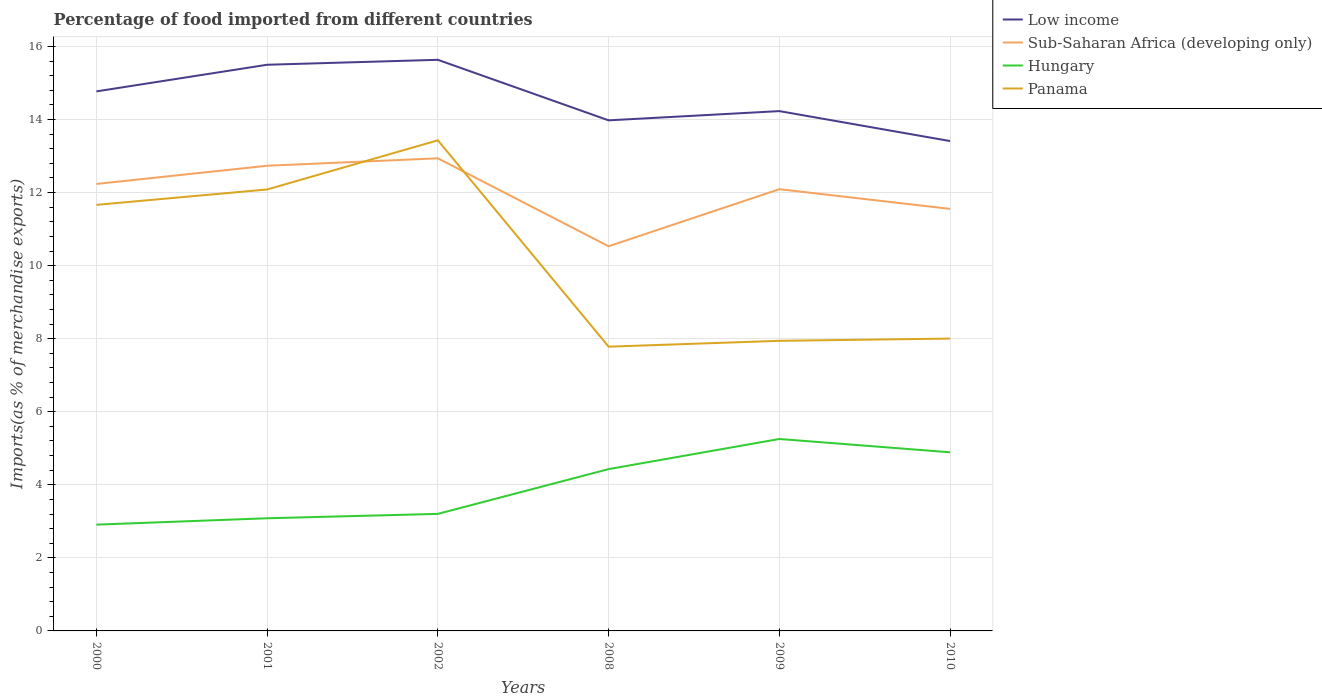How many different coloured lines are there?
Keep it short and to the point. 4. Is the number of lines equal to the number of legend labels?
Offer a terse response. Yes. Across all years, what is the maximum percentage of imports to different countries in Low income?
Provide a short and direct response. 13.41. In which year was the percentage of imports to different countries in Hungary maximum?
Offer a terse response. 2000. What is the total percentage of imports to different countries in Low income in the graph?
Your answer should be very brief. -0.14. What is the difference between the highest and the second highest percentage of imports to different countries in Low income?
Make the answer very short. 2.22. What is the difference between the highest and the lowest percentage of imports to different countries in Low income?
Your answer should be very brief. 3. How many lines are there?
Offer a very short reply. 4. What is the difference between two consecutive major ticks on the Y-axis?
Ensure brevity in your answer.  2. Are the values on the major ticks of Y-axis written in scientific E-notation?
Your answer should be compact. No. Does the graph contain any zero values?
Ensure brevity in your answer.  No. Does the graph contain grids?
Provide a short and direct response. Yes. How are the legend labels stacked?
Your answer should be very brief. Vertical. What is the title of the graph?
Offer a terse response. Percentage of food imported from different countries. What is the label or title of the X-axis?
Provide a short and direct response. Years. What is the label or title of the Y-axis?
Offer a very short reply. Imports(as % of merchandise exports). What is the Imports(as % of merchandise exports) of Low income in 2000?
Your answer should be compact. 14.77. What is the Imports(as % of merchandise exports) in Sub-Saharan Africa (developing only) in 2000?
Provide a short and direct response. 12.24. What is the Imports(as % of merchandise exports) of Hungary in 2000?
Provide a succinct answer. 2.91. What is the Imports(as % of merchandise exports) of Panama in 2000?
Make the answer very short. 11.66. What is the Imports(as % of merchandise exports) of Low income in 2001?
Make the answer very short. 15.5. What is the Imports(as % of merchandise exports) in Sub-Saharan Africa (developing only) in 2001?
Your response must be concise. 12.74. What is the Imports(as % of merchandise exports) of Hungary in 2001?
Make the answer very short. 3.08. What is the Imports(as % of merchandise exports) of Panama in 2001?
Provide a succinct answer. 12.09. What is the Imports(as % of merchandise exports) of Low income in 2002?
Provide a succinct answer. 15.64. What is the Imports(as % of merchandise exports) of Sub-Saharan Africa (developing only) in 2002?
Offer a terse response. 12.94. What is the Imports(as % of merchandise exports) in Hungary in 2002?
Offer a terse response. 3.2. What is the Imports(as % of merchandise exports) in Panama in 2002?
Your answer should be compact. 13.43. What is the Imports(as % of merchandise exports) in Low income in 2008?
Keep it short and to the point. 13.98. What is the Imports(as % of merchandise exports) in Sub-Saharan Africa (developing only) in 2008?
Offer a very short reply. 10.53. What is the Imports(as % of merchandise exports) in Hungary in 2008?
Provide a succinct answer. 4.43. What is the Imports(as % of merchandise exports) in Panama in 2008?
Give a very brief answer. 7.78. What is the Imports(as % of merchandise exports) in Low income in 2009?
Your answer should be very brief. 14.23. What is the Imports(as % of merchandise exports) in Sub-Saharan Africa (developing only) in 2009?
Offer a terse response. 12.09. What is the Imports(as % of merchandise exports) in Hungary in 2009?
Ensure brevity in your answer.  5.25. What is the Imports(as % of merchandise exports) in Panama in 2009?
Your response must be concise. 7.94. What is the Imports(as % of merchandise exports) in Low income in 2010?
Offer a very short reply. 13.41. What is the Imports(as % of merchandise exports) of Sub-Saharan Africa (developing only) in 2010?
Provide a short and direct response. 11.55. What is the Imports(as % of merchandise exports) of Hungary in 2010?
Offer a terse response. 4.89. What is the Imports(as % of merchandise exports) in Panama in 2010?
Offer a terse response. 8. Across all years, what is the maximum Imports(as % of merchandise exports) of Low income?
Your response must be concise. 15.64. Across all years, what is the maximum Imports(as % of merchandise exports) in Sub-Saharan Africa (developing only)?
Provide a succinct answer. 12.94. Across all years, what is the maximum Imports(as % of merchandise exports) of Hungary?
Your response must be concise. 5.25. Across all years, what is the maximum Imports(as % of merchandise exports) of Panama?
Offer a terse response. 13.43. Across all years, what is the minimum Imports(as % of merchandise exports) of Low income?
Your answer should be compact. 13.41. Across all years, what is the minimum Imports(as % of merchandise exports) in Sub-Saharan Africa (developing only)?
Provide a succinct answer. 10.53. Across all years, what is the minimum Imports(as % of merchandise exports) of Hungary?
Keep it short and to the point. 2.91. Across all years, what is the minimum Imports(as % of merchandise exports) of Panama?
Offer a very short reply. 7.78. What is the total Imports(as % of merchandise exports) in Low income in the graph?
Your answer should be very brief. 87.53. What is the total Imports(as % of merchandise exports) of Sub-Saharan Africa (developing only) in the graph?
Provide a succinct answer. 72.09. What is the total Imports(as % of merchandise exports) in Hungary in the graph?
Offer a very short reply. 23.77. What is the total Imports(as % of merchandise exports) of Panama in the graph?
Give a very brief answer. 60.91. What is the difference between the Imports(as % of merchandise exports) in Low income in 2000 and that in 2001?
Make the answer very short. -0.73. What is the difference between the Imports(as % of merchandise exports) in Sub-Saharan Africa (developing only) in 2000 and that in 2001?
Give a very brief answer. -0.5. What is the difference between the Imports(as % of merchandise exports) of Hungary in 2000 and that in 2001?
Offer a very short reply. -0.17. What is the difference between the Imports(as % of merchandise exports) of Panama in 2000 and that in 2001?
Make the answer very short. -0.42. What is the difference between the Imports(as % of merchandise exports) in Low income in 2000 and that in 2002?
Give a very brief answer. -0.86. What is the difference between the Imports(as % of merchandise exports) in Sub-Saharan Africa (developing only) in 2000 and that in 2002?
Offer a very short reply. -0.7. What is the difference between the Imports(as % of merchandise exports) of Hungary in 2000 and that in 2002?
Provide a short and direct response. -0.29. What is the difference between the Imports(as % of merchandise exports) of Panama in 2000 and that in 2002?
Your response must be concise. -1.77. What is the difference between the Imports(as % of merchandise exports) of Low income in 2000 and that in 2008?
Provide a short and direct response. 0.79. What is the difference between the Imports(as % of merchandise exports) of Sub-Saharan Africa (developing only) in 2000 and that in 2008?
Ensure brevity in your answer.  1.71. What is the difference between the Imports(as % of merchandise exports) in Hungary in 2000 and that in 2008?
Your answer should be compact. -1.52. What is the difference between the Imports(as % of merchandise exports) of Panama in 2000 and that in 2008?
Provide a succinct answer. 3.88. What is the difference between the Imports(as % of merchandise exports) in Low income in 2000 and that in 2009?
Make the answer very short. 0.54. What is the difference between the Imports(as % of merchandise exports) in Sub-Saharan Africa (developing only) in 2000 and that in 2009?
Provide a succinct answer. 0.14. What is the difference between the Imports(as % of merchandise exports) of Hungary in 2000 and that in 2009?
Provide a short and direct response. -2.35. What is the difference between the Imports(as % of merchandise exports) in Panama in 2000 and that in 2009?
Make the answer very short. 3.72. What is the difference between the Imports(as % of merchandise exports) in Low income in 2000 and that in 2010?
Offer a terse response. 1.36. What is the difference between the Imports(as % of merchandise exports) in Sub-Saharan Africa (developing only) in 2000 and that in 2010?
Your answer should be very brief. 0.68. What is the difference between the Imports(as % of merchandise exports) of Hungary in 2000 and that in 2010?
Provide a short and direct response. -1.98. What is the difference between the Imports(as % of merchandise exports) of Panama in 2000 and that in 2010?
Provide a short and direct response. 3.66. What is the difference between the Imports(as % of merchandise exports) of Low income in 2001 and that in 2002?
Ensure brevity in your answer.  -0.14. What is the difference between the Imports(as % of merchandise exports) of Sub-Saharan Africa (developing only) in 2001 and that in 2002?
Keep it short and to the point. -0.2. What is the difference between the Imports(as % of merchandise exports) of Hungary in 2001 and that in 2002?
Offer a very short reply. -0.12. What is the difference between the Imports(as % of merchandise exports) of Panama in 2001 and that in 2002?
Your answer should be very brief. -1.35. What is the difference between the Imports(as % of merchandise exports) in Low income in 2001 and that in 2008?
Ensure brevity in your answer.  1.52. What is the difference between the Imports(as % of merchandise exports) in Sub-Saharan Africa (developing only) in 2001 and that in 2008?
Your answer should be compact. 2.2. What is the difference between the Imports(as % of merchandise exports) in Hungary in 2001 and that in 2008?
Offer a terse response. -1.35. What is the difference between the Imports(as % of merchandise exports) of Panama in 2001 and that in 2008?
Make the answer very short. 4.3. What is the difference between the Imports(as % of merchandise exports) of Low income in 2001 and that in 2009?
Provide a short and direct response. 1.27. What is the difference between the Imports(as % of merchandise exports) of Sub-Saharan Africa (developing only) in 2001 and that in 2009?
Make the answer very short. 0.64. What is the difference between the Imports(as % of merchandise exports) of Hungary in 2001 and that in 2009?
Provide a succinct answer. -2.17. What is the difference between the Imports(as % of merchandise exports) in Panama in 2001 and that in 2009?
Ensure brevity in your answer.  4.14. What is the difference between the Imports(as % of merchandise exports) of Low income in 2001 and that in 2010?
Ensure brevity in your answer.  2.09. What is the difference between the Imports(as % of merchandise exports) in Sub-Saharan Africa (developing only) in 2001 and that in 2010?
Give a very brief answer. 1.18. What is the difference between the Imports(as % of merchandise exports) in Hungary in 2001 and that in 2010?
Your answer should be compact. -1.81. What is the difference between the Imports(as % of merchandise exports) of Panama in 2001 and that in 2010?
Ensure brevity in your answer.  4.08. What is the difference between the Imports(as % of merchandise exports) of Low income in 2002 and that in 2008?
Your response must be concise. 1.66. What is the difference between the Imports(as % of merchandise exports) in Sub-Saharan Africa (developing only) in 2002 and that in 2008?
Your answer should be compact. 2.41. What is the difference between the Imports(as % of merchandise exports) of Hungary in 2002 and that in 2008?
Offer a terse response. -1.23. What is the difference between the Imports(as % of merchandise exports) in Panama in 2002 and that in 2008?
Your response must be concise. 5.65. What is the difference between the Imports(as % of merchandise exports) of Low income in 2002 and that in 2009?
Provide a short and direct response. 1.4. What is the difference between the Imports(as % of merchandise exports) in Sub-Saharan Africa (developing only) in 2002 and that in 2009?
Your answer should be very brief. 0.85. What is the difference between the Imports(as % of merchandise exports) in Hungary in 2002 and that in 2009?
Provide a short and direct response. -2.05. What is the difference between the Imports(as % of merchandise exports) in Panama in 2002 and that in 2009?
Offer a very short reply. 5.49. What is the difference between the Imports(as % of merchandise exports) of Low income in 2002 and that in 2010?
Provide a short and direct response. 2.22. What is the difference between the Imports(as % of merchandise exports) of Sub-Saharan Africa (developing only) in 2002 and that in 2010?
Give a very brief answer. 1.38. What is the difference between the Imports(as % of merchandise exports) of Hungary in 2002 and that in 2010?
Your answer should be compact. -1.69. What is the difference between the Imports(as % of merchandise exports) of Panama in 2002 and that in 2010?
Give a very brief answer. 5.43. What is the difference between the Imports(as % of merchandise exports) of Low income in 2008 and that in 2009?
Make the answer very short. -0.25. What is the difference between the Imports(as % of merchandise exports) of Sub-Saharan Africa (developing only) in 2008 and that in 2009?
Provide a short and direct response. -1.56. What is the difference between the Imports(as % of merchandise exports) in Hungary in 2008 and that in 2009?
Keep it short and to the point. -0.82. What is the difference between the Imports(as % of merchandise exports) in Panama in 2008 and that in 2009?
Provide a succinct answer. -0.16. What is the difference between the Imports(as % of merchandise exports) in Low income in 2008 and that in 2010?
Give a very brief answer. 0.57. What is the difference between the Imports(as % of merchandise exports) in Sub-Saharan Africa (developing only) in 2008 and that in 2010?
Give a very brief answer. -1.02. What is the difference between the Imports(as % of merchandise exports) in Hungary in 2008 and that in 2010?
Your response must be concise. -0.46. What is the difference between the Imports(as % of merchandise exports) of Panama in 2008 and that in 2010?
Your response must be concise. -0.22. What is the difference between the Imports(as % of merchandise exports) of Low income in 2009 and that in 2010?
Ensure brevity in your answer.  0.82. What is the difference between the Imports(as % of merchandise exports) of Sub-Saharan Africa (developing only) in 2009 and that in 2010?
Give a very brief answer. 0.54. What is the difference between the Imports(as % of merchandise exports) in Hungary in 2009 and that in 2010?
Your response must be concise. 0.36. What is the difference between the Imports(as % of merchandise exports) of Panama in 2009 and that in 2010?
Make the answer very short. -0.06. What is the difference between the Imports(as % of merchandise exports) in Low income in 2000 and the Imports(as % of merchandise exports) in Sub-Saharan Africa (developing only) in 2001?
Provide a short and direct response. 2.04. What is the difference between the Imports(as % of merchandise exports) of Low income in 2000 and the Imports(as % of merchandise exports) of Hungary in 2001?
Your response must be concise. 11.69. What is the difference between the Imports(as % of merchandise exports) of Low income in 2000 and the Imports(as % of merchandise exports) of Panama in 2001?
Keep it short and to the point. 2.69. What is the difference between the Imports(as % of merchandise exports) of Sub-Saharan Africa (developing only) in 2000 and the Imports(as % of merchandise exports) of Hungary in 2001?
Your answer should be very brief. 9.15. What is the difference between the Imports(as % of merchandise exports) in Sub-Saharan Africa (developing only) in 2000 and the Imports(as % of merchandise exports) in Panama in 2001?
Your answer should be compact. 0.15. What is the difference between the Imports(as % of merchandise exports) in Hungary in 2000 and the Imports(as % of merchandise exports) in Panama in 2001?
Ensure brevity in your answer.  -9.18. What is the difference between the Imports(as % of merchandise exports) of Low income in 2000 and the Imports(as % of merchandise exports) of Sub-Saharan Africa (developing only) in 2002?
Provide a succinct answer. 1.83. What is the difference between the Imports(as % of merchandise exports) of Low income in 2000 and the Imports(as % of merchandise exports) of Hungary in 2002?
Make the answer very short. 11.57. What is the difference between the Imports(as % of merchandise exports) in Low income in 2000 and the Imports(as % of merchandise exports) in Panama in 2002?
Your answer should be compact. 1.34. What is the difference between the Imports(as % of merchandise exports) of Sub-Saharan Africa (developing only) in 2000 and the Imports(as % of merchandise exports) of Hungary in 2002?
Provide a short and direct response. 9.03. What is the difference between the Imports(as % of merchandise exports) in Sub-Saharan Africa (developing only) in 2000 and the Imports(as % of merchandise exports) in Panama in 2002?
Make the answer very short. -1.19. What is the difference between the Imports(as % of merchandise exports) of Hungary in 2000 and the Imports(as % of merchandise exports) of Panama in 2002?
Ensure brevity in your answer.  -10.52. What is the difference between the Imports(as % of merchandise exports) in Low income in 2000 and the Imports(as % of merchandise exports) in Sub-Saharan Africa (developing only) in 2008?
Give a very brief answer. 4.24. What is the difference between the Imports(as % of merchandise exports) in Low income in 2000 and the Imports(as % of merchandise exports) in Hungary in 2008?
Your answer should be very brief. 10.34. What is the difference between the Imports(as % of merchandise exports) in Low income in 2000 and the Imports(as % of merchandise exports) in Panama in 2008?
Your answer should be compact. 6.99. What is the difference between the Imports(as % of merchandise exports) in Sub-Saharan Africa (developing only) in 2000 and the Imports(as % of merchandise exports) in Hungary in 2008?
Provide a succinct answer. 7.81. What is the difference between the Imports(as % of merchandise exports) in Sub-Saharan Africa (developing only) in 2000 and the Imports(as % of merchandise exports) in Panama in 2008?
Your answer should be very brief. 4.46. What is the difference between the Imports(as % of merchandise exports) in Hungary in 2000 and the Imports(as % of merchandise exports) in Panama in 2008?
Ensure brevity in your answer.  -4.87. What is the difference between the Imports(as % of merchandise exports) of Low income in 2000 and the Imports(as % of merchandise exports) of Sub-Saharan Africa (developing only) in 2009?
Your answer should be very brief. 2.68. What is the difference between the Imports(as % of merchandise exports) of Low income in 2000 and the Imports(as % of merchandise exports) of Hungary in 2009?
Provide a short and direct response. 9.52. What is the difference between the Imports(as % of merchandise exports) of Low income in 2000 and the Imports(as % of merchandise exports) of Panama in 2009?
Ensure brevity in your answer.  6.83. What is the difference between the Imports(as % of merchandise exports) in Sub-Saharan Africa (developing only) in 2000 and the Imports(as % of merchandise exports) in Hungary in 2009?
Your answer should be compact. 6.98. What is the difference between the Imports(as % of merchandise exports) in Sub-Saharan Africa (developing only) in 2000 and the Imports(as % of merchandise exports) in Panama in 2009?
Your response must be concise. 4.29. What is the difference between the Imports(as % of merchandise exports) in Hungary in 2000 and the Imports(as % of merchandise exports) in Panama in 2009?
Make the answer very short. -5.03. What is the difference between the Imports(as % of merchandise exports) in Low income in 2000 and the Imports(as % of merchandise exports) in Sub-Saharan Africa (developing only) in 2010?
Offer a very short reply. 3.22. What is the difference between the Imports(as % of merchandise exports) in Low income in 2000 and the Imports(as % of merchandise exports) in Hungary in 2010?
Keep it short and to the point. 9.88. What is the difference between the Imports(as % of merchandise exports) of Low income in 2000 and the Imports(as % of merchandise exports) of Panama in 2010?
Make the answer very short. 6.77. What is the difference between the Imports(as % of merchandise exports) in Sub-Saharan Africa (developing only) in 2000 and the Imports(as % of merchandise exports) in Hungary in 2010?
Your answer should be very brief. 7.35. What is the difference between the Imports(as % of merchandise exports) in Sub-Saharan Africa (developing only) in 2000 and the Imports(as % of merchandise exports) in Panama in 2010?
Ensure brevity in your answer.  4.23. What is the difference between the Imports(as % of merchandise exports) in Hungary in 2000 and the Imports(as % of merchandise exports) in Panama in 2010?
Offer a very short reply. -5.09. What is the difference between the Imports(as % of merchandise exports) in Low income in 2001 and the Imports(as % of merchandise exports) in Sub-Saharan Africa (developing only) in 2002?
Your answer should be very brief. 2.56. What is the difference between the Imports(as % of merchandise exports) in Low income in 2001 and the Imports(as % of merchandise exports) in Hungary in 2002?
Ensure brevity in your answer.  12.3. What is the difference between the Imports(as % of merchandise exports) of Low income in 2001 and the Imports(as % of merchandise exports) of Panama in 2002?
Provide a short and direct response. 2.07. What is the difference between the Imports(as % of merchandise exports) of Sub-Saharan Africa (developing only) in 2001 and the Imports(as % of merchandise exports) of Hungary in 2002?
Give a very brief answer. 9.53. What is the difference between the Imports(as % of merchandise exports) in Sub-Saharan Africa (developing only) in 2001 and the Imports(as % of merchandise exports) in Panama in 2002?
Make the answer very short. -0.7. What is the difference between the Imports(as % of merchandise exports) in Hungary in 2001 and the Imports(as % of merchandise exports) in Panama in 2002?
Keep it short and to the point. -10.35. What is the difference between the Imports(as % of merchandise exports) in Low income in 2001 and the Imports(as % of merchandise exports) in Sub-Saharan Africa (developing only) in 2008?
Your answer should be very brief. 4.97. What is the difference between the Imports(as % of merchandise exports) in Low income in 2001 and the Imports(as % of merchandise exports) in Hungary in 2008?
Provide a short and direct response. 11.07. What is the difference between the Imports(as % of merchandise exports) of Low income in 2001 and the Imports(as % of merchandise exports) of Panama in 2008?
Your response must be concise. 7.72. What is the difference between the Imports(as % of merchandise exports) in Sub-Saharan Africa (developing only) in 2001 and the Imports(as % of merchandise exports) in Hungary in 2008?
Your response must be concise. 8.31. What is the difference between the Imports(as % of merchandise exports) in Sub-Saharan Africa (developing only) in 2001 and the Imports(as % of merchandise exports) in Panama in 2008?
Your answer should be compact. 4.95. What is the difference between the Imports(as % of merchandise exports) of Hungary in 2001 and the Imports(as % of merchandise exports) of Panama in 2008?
Provide a succinct answer. -4.7. What is the difference between the Imports(as % of merchandise exports) of Low income in 2001 and the Imports(as % of merchandise exports) of Sub-Saharan Africa (developing only) in 2009?
Provide a succinct answer. 3.41. What is the difference between the Imports(as % of merchandise exports) of Low income in 2001 and the Imports(as % of merchandise exports) of Hungary in 2009?
Your answer should be very brief. 10.25. What is the difference between the Imports(as % of merchandise exports) of Low income in 2001 and the Imports(as % of merchandise exports) of Panama in 2009?
Your response must be concise. 7.56. What is the difference between the Imports(as % of merchandise exports) of Sub-Saharan Africa (developing only) in 2001 and the Imports(as % of merchandise exports) of Hungary in 2009?
Offer a terse response. 7.48. What is the difference between the Imports(as % of merchandise exports) in Sub-Saharan Africa (developing only) in 2001 and the Imports(as % of merchandise exports) in Panama in 2009?
Your answer should be very brief. 4.79. What is the difference between the Imports(as % of merchandise exports) of Hungary in 2001 and the Imports(as % of merchandise exports) of Panama in 2009?
Give a very brief answer. -4.86. What is the difference between the Imports(as % of merchandise exports) of Low income in 2001 and the Imports(as % of merchandise exports) of Sub-Saharan Africa (developing only) in 2010?
Your answer should be very brief. 3.95. What is the difference between the Imports(as % of merchandise exports) of Low income in 2001 and the Imports(as % of merchandise exports) of Hungary in 2010?
Offer a very short reply. 10.61. What is the difference between the Imports(as % of merchandise exports) of Low income in 2001 and the Imports(as % of merchandise exports) of Panama in 2010?
Your answer should be compact. 7.5. What is the difference between the Imports(as % of merchandise exports) in Sub-Saharan Africa (developing only) in 2001 and the Imports(as % of merchandise exports) in Hungary in 2010?
Your answer should be compact. 7.84. What is the difference between the Imports(as % of merchandise exports) of Sub-Saharan Africa (developing only) in 2001 and the Imports(as % of merchandise exports) of Panama in 2010?
Offer a very short reply. 4.73. What is the difference between the Imports(as % of merchandise exports) of Hungary in 2001 and the Imports(as % of merchandise exports) of Panama in 2010?
Offer a very short reply. -4.92. What is the difference between the Imports(as % of merchandise exports) in Low income in 2002 and the Imports(as % of merchandise exports) in Sub-Saharan Africa (developing only) in 2008?
Keep it short and to the point. 5.1. What is the difference between the Imports(as % of merchandise exports) of Low income in 2002 and the Imports(as % of merchandise exports) of Hungary in 2008?
Your response must be concise. 11.21. What is the difference between the Imports(as % of merchandise exports) in Low income in 2002 and the Imports(as % of merchandise exports) in Panama in 2008?
Provide a short and direct response. 7.85. What is the difference between the Imports(as % of merchandise exports) of Sub-Saharan Africa (developing only) in 2002 and the Imports(as % of merchandise exports) of Hungary in 2008?
Provide a succinct answer. 8.51. What is the difference between the Imports(as % of merchandise exports) of Sub-Saharan Africa (developing only) in 2002 and the Imports(as % of merchandise exports) of Panama in 2008?
Provide a succinct answer. 5.16. What is the difference between the Imports(as % of merchandise exports) of Hungary in 2002 and the Imports(as % of merchandise exports) of Panama in 2008?
Give a very brief answer. -4.58. What is the difference between the Imports(as % of merchandise exports) of Low income in 2002 and the Imports(as % of merchandise exports) of Sub-Saharan Africa (developing only) in 2009?
Your answer should be compact. 3.54. What is the difference between the Imports(as % of merchandise exports) in Low income in 2002 and the Imports(as % of merchandise exports) in Hungary in 2009?
Give a very brief answer. 10.38. What is the difference between the Imports(as % of merchandise exports) of Low income in 2002 and the Imports(as % of merchandise exports) of Panama in 2009?
Provide a succinct answer. 7.69. What is the difference between the Imports(as % of merchandise exports) of Sub-Saharan Africa (developing only) in 2002 and the Imports(as % of merchandise exports) of Hungary in 2009?
Give a very brief answer. 7.68. What is the difference between the Imports(as % of merchandise exports) in Sub-Saharan Africa (developing only) in 2002 and the Imports(as % of merchandise exports) in Panama in 2009?
Provide a succinct answer. 5. What is the difference between the Imports(as % of merchandise exports) in Hungary in 2002 and the Imports(as % of merchandise exports) in Panama in 2009?
Give a very brief answer. -4.74. What is the difference between the Imports(as % of merchandise exports) in Low income in 2002 and the Imports(as % of merchandise exports) in Sub-Saharan Africa (developing only) in 2010?
Ensure brevity in your answer.  4.08. What is the difference between the Imports(as % of merchandise exports) of Low income in 2002 and the Imports(as % of merchandise exports) of Hungary in 2010?
Keep it short and to the point. 10.74. What is the difference between the Imports(as % of merchandise exports) of Low income in 2002 and the Imports(as % of merchandise exports) of Panama in 2010?
Give a very brief answer. 7.63. What is the difference between the Imports(as % of merchandise exports) of Sub-Saharan Africa (developing only) in 2002 and the Imports(as % of merchandise exports) of Hungary in 2010?
Provide a short and direct response. 8.05. What is the difference between the Imports(as % of merchandise exports) of Sub-Saharan Africa (developing only) in 2002 and the Imports(as % of merchandise exports) of Panama in 2010?
Give a very brief answer. 4.94. What is the difference between the Imports(as % of merchandise exports) of Hungary in 2002 and the Imports(as % of merchandise exports) of Panama in 2010?
Your answer should be very brief. -4.8. What is the difference between the Imports(as % of merchandise exports) in Low income in 2008 and the Imports(as % of merchandise exports) in Sub-Saharan Africa (developing only) in 2009?
Your answer should be compact. 1.89. What is the difference between the Imports(as % of merchandise exports) of Low income in 2008 and the Imports(as % of merchandise exports) of Hungary in 2009?
Keep it short and to the point. 8.72. What is the difference between the Imports(as % of merchandise exports) in Low income in 2008 and the Imports(as % of merchandise exports) in Panama in 2009?
Make the answer very short. 6.04. What is the difference between the Imports(as % of merchandise exports) in Sub-Saharan Africa (developing only) in 2008 and the Imports(as % of merchandise exports) in Hungary in 2009?
Your answer should be very brief. 5.28. What is the difference between the Imports(as % of merchandise exports) in Sub-Saharan Africa (developing only) in 2008 and the Imports(as % of merchandise exports) in Panama in 2009?
Provide a succinct answer. 2.59. What is the difference between the Imports(as % of merchandise exports) of Hungary in 2008 and the Imports(as % of merchandise exports) of Panama in 2009?
Provide a succinct answer. -3.51. What is the difference between the Imports(as % of merchandise exports) in Low income in 2008 and the Imports(as % of merchandise exports) in Sub-Saharan Africa (developing only) in 2010?
Make the answer very short. 2.42. What is the difference between the Imports(as % of merchandise exports) in Low income in 2008 and the Imports(as % of merchandise exports) in Hungary in 2010?
Your answer should be very brief. 9.09. What is the difference between the Imports(as % of merchandise exports) of Low income in 2008 and the Imports(as % of merchandise exports) of Panama in 2010?
Offer a very short reply. 5.97. What is the difference between the Imports(as % of merchandise exports) of Sub-Saharan Africa (developing only) in 2008 and the Imports(as % of merchandise exports) of Hungary in 2010?
Keep it short and to the point. 5.64. What is the difference between the Imports(as % of merchandise exports) in Sub-Saharan Africa (developing only) in 2008 and the Imports(as % of merchandise exports) in Panama in 2010?
Your response must be concise. 2.53. What is the difference between the Imports(as % of merchandise exports) in Hungary in 2008 and the Imports(as % of merchandise exports) in Panama in 2010?
Your answer should be very brief. -3.57. What is the difference between the Imports(as % of merchandise exports) of Low income in 2009 and the Imports(as % of merchandise exports) of Sub-Saharan Africa (developing only) in 2010?
Offer a very short reply. 2.68. What is the difference between the Imports(as % of merchandise exports) in Low income in 2009 and the Imports(as % of merchandise exports) in Hungary in 2010?
Make the answer very short. 9.34. What is the difference between the Imports(as % of merchandise exports) in Low income in 2009 and the Imports(as % of merchandise exports) in Panama in 2010?
Ensure brevity in your answer.  6.23. What is the difference between the Imports(as % of merchandise exports) of Sub-Saharan Africa (developing only) in 2009 and the Imports(as % of merchandise exports) of Hungary in 2010?
Your answer should be very brief. 7.2. What is the difference between the Imports(as % of merchandise exports) of Sub-Saharan Africa (developing only) in 2009 and the Imports(as % of merchandise exports) of Panama in 2010?
Your answer should be compact. 4.09. What is the difference between the Imports(as % of merchandise exports) in Hungary in 2009 and the Imports(as % of merchandise exports) in Panama in 2010?
Offer a very short reply. -2.75. What is the average Imports(as % of merchandise exports) of Low income per year?
Provide a short and direct response. 14.59. What is the average Imports(as % of merchandise exports) of Sub-Saharan Africa (developing only) per year?
Offer a terse response. 12.02. What is the average Imports(as % of merchandise exports) of Hungary per year?
Make the answer very short. 3.96. What is the average Imports(as % of merchandise exports) in Panama per year?
Provide a succinct answer. 10.15. In the year 2000, what is the difference between the Imports(as % of merchandise exports) in Low income and Imports(as % of merchandise exports) in Sub-Saharan Africa (developing only)?
Offer a very short reply. 2.53. In the year 2000, what is the difference between the Imports(as % of merchandise exports) in Low income and Imports(as % of merchandise exports) in Hungary?
Keep it short and to the point. 11.86. In the year 2000, what is the difference between the Imports(as % of merchandise exports) in Low income and Imports(as % of merchandise exports) in Panama?
Make the answer very short. 3.11. In the year 2000, what is the difference between the Imports(as % of merchandise exports) in Sub-Saharan Africa (developing only) and Imports(as % of merchandise exports) in Hungary?
Give a very brief answer. 9.33. In the year 2000, what is the difference between the Imports(as % of merchandise exports) in Sub-Saharan Africa (developing only) and Imports(as % of merchandise exports) in Panama?
Make the answer very short. 0.57. In the year 2000, what is the difference between the Imports(as % of merchandise exports) of Hungary and Imports(as % of merchandise exports) of Panama?
Make the answer very short. -8.75. In the year 2001, what is the difference between the Imports(as % of merchandise exports) in Low income and Imports(as % of merchandise exports) in Sub-Saharan Africa (developing only)?
Ensure brevity in your answer.  2.77. In the year 2001, what is the difference between the Imports(as % of merchandise exports) in Low income and Imports(as % of merchandise exports) in Hungary?
Make the answer very short. 12.42. In the year 2001, what is the difference between the Imports(as % of merchandise exports) in Low income and Imports(as % of merchandise exports) in Panama?
Give a very brief answer. 3.41. In the year 2001, what is the difference between the Imports(as % of merchandise exports) in Sub-Saharan Africa (developing only) and Imports(as % of merchandise exports) in Hungary?
Your response must be concise. 9.65. In the year 2001, what is the difference between the Imports(as % of merchandise exports) of Sub-Saharan Africa (developing only) and Imports(as % of merchandise exports) of Panama?
Your answer should be very brief. 0.65. In the year 2001, what is the difference between the Imports(as % of merchandise exports) of Hungary and Imports(as % of merchandise exports) of Panama?
Offer a very short reply. -9. In the year 2002, what is the difference between the Imports(as % of merchandise exports) in Low income and Imports(as % of merchandise exports) in Sub-Saharan Africa (developing only)?
Your answer should be compact. 2.7. In the year 2002, what is the difference between the Imports(as % of merchandise exports) of Low income and Imports(as % of merchandise exports) of Hungary?
Offer a terse response. 12.43. In the year 2002, what is the difference between the Imports(as % of merchandise exports) of Low income and Imports(as % of merchandise exports) of Panama?
Ensure brevity in your answer.  2.2. In the year 2002, what is the difference between the Imports(as % of merchandise exports) of Sub-Saharan Africa (developing only) and Imports(as % of merchandise exports) of Hungary?
Ensure brevity in your answer.  9.73. In the year 2002, what is the difference between the Imports(as % of merchandise exports) in Sub-Saharan Africa (developing only) and Imports(as % of merchandise exports) in Panama?
Offer a very short reply. -0.49. In the year 2002, what is the difference between the Imports(as % of merchandise exports) of Hungary and Imports(as % of merchandise exports) of Panama?
Give a very brief answer. -10.23. In the year 2008, what is the difference between the Imports(as % of merchandise exports) of Low income and Imports(as % of merchandise exports) of Sub-Saharan Africa (developing only)?
Provide a succinct answer. 3.45. In the year 2008, what is the difference between the Imports(as % of merchandise exports) in Low income and Imports(as % of merchandise exports) in Hungary?
Provide a short and direct response. 9.55. In the year 2008, what is the difference between the Imports(as % of merchandise exports) in Low income and Imports(as % of merchandise exports) in Panama?
Provide a short and direct response. 6.2. In the year 2008, what is the difference between the Imports(as % of merchandise exports) of Sub-Saharan Africa (developing only) and Imports(as % of merchandise exports) of Hungary?
Your response must be concise. 6.1. In the year 2008, what is the difference between the Imports(as % of merchandise exports) of Sub-Saharan Africa (developing only) and Imports(as % of merchandise exports) of Panama?
Your response must be concise. 2.75. In the year 2008, what is the difference between the Imports(as % of merchandise exports) of Hungary and Imports(as % of merchandise exports) of Panama?
Make the answer very short. -3.35. In the year 2009, what is the difference between the Imports(as % of merchandise exports) in Low income and Imports(as % of merchandise exports) in Sub-Saharan Africa (developing only)?
Offer a terse response. 2.14. In the year 2009, what is the difference between the Imports(as % of merchandise exports) of Low income and Imports(as % of merchandise exports) of Hungary?
Ensure brevity in your answer.  8.98. In the year 2009, what is the difference between the Imports(as % of merchandise exports) in Low income and Imports(as % of merchandise exports) in Panama?
Your response must be concise. 6.29. In the year 2009, what is the difference between the Imports(as % of merchandise exports) in Sub-Saharan Africa (developing only) and Imports(as % of merchandise exports) in Hungary?
Your answer should be very brief. 6.84. In the year 2009, what is the difference between the Imports(as % of merchandise exports) in Sub-Saharan Africa (developing only) and Imports(as % of merchandise exports) in Panama?
Make the answer very short. 4.15. In the year 2009, what is the difference between the Imports(as % of merchandise exports) in Hungary and Imports(as % of merchandise exports) in Panama?
Ensure brevity in your answer.  -2.69. In the year 2010, what is the difference between the Imports(as % of merchandise exports) of Low income and Imports(as % of merchandise exports) of Sub-Saharan Africa (developing only)?
Your answer should be compact. 1.86. In the year 2010, what is the difference between the Imports(as % of merchandise exports) of Low income and Imports(as % of merchandise exports) of Hungary?
Keep it short and to the point. 8.52. In the year 2010, what is the difference between the Imports(as % of merchandise exports) of Low income and Imports(as % of merchandise exports) of Panama?
Provide a short and direct response. 5.41. In the year 2010, what is the difference between the Imports(as % of merchandise exports) in Sub-Saharan Africa (developing only) and Imports(as % of merchandise exports) in Hungary?
Offer a terse response. 6.66. In the year 2010, what is the difference between the Imports(as % of merchandise exports) in Sub-Saharan Africa (developing only) and Imports(as % of merchandise exports) in Panama?
Offer a very short reply. 3.55. In the year 2010, what is the difference between the Imports(as % of merchandise exports) in Hungary and Imports(as % of merchandise exports) in Panama?
Provide a succinct answer. -3.11. What is the ratio of the Imports(as % of merchandise exports) in Low income in 2000 to that in 2001?
Offer a very short reply. 0.95. What is the ratio of the Imports(as % of merchandise exports) of Sub-Saharan Africa (developing only) in 2000 to that in 2001?
Offer a terse response. 0.96. What is the ratio of the Imports(as % of merchandise exports) in Hungary in 2000 to that in 2001?
Keep it short and to the point. 0.94. What is the ratio of the Imports(as % of merchandise exports) in Panama in 2000 to that in 2001?
Make the answer very short. 0.97. What is the ratio of the Imports(as % of merchandise exports) in Low income in 2000 to that in 2002?
Provide a succinct answer. 0.94. What is the ratio of the Imports(as % of merchandise exports) of Sub-Saharan Africa (developing only) in 2000 to that in 2002?
Provide a succinct answer. 0.95. What is the ratio of the Imports(as % of merchandise exports) in Hungary in 2000 to that in 2002?
Give a very brief answer. 0.91. What is the ratio of the Imports(as % of merchandise exports) of Panama in 2000 to that in 2002?
Provide a short and direct response. 0.87. What is the ratio of the Imports(as % of merchandise exports) of Low income in 2000 to that in 2008?
Make the answer very short. 1.06. What is the ratio of the Imports(as % of merchandise exports) of Sub-Saharan Africa (developing only) in 2000 to that in 2008?
Keep it short and to the point. 1.16. What is the ratio of the Imports(as % of merchandise exports) in Hungary in 2000 to that in 2008?
Your answer should be compact. 0.66. What is the ratio of the Imports(as % of merchandise exports) of Panama in 2000 to that in 2008?
Your answer should be compact. 1.5. What is the ratio of the Imports(as % of merchandise exports) in Low income in 2000 to that in 2009?
Provide a succinct answer. 1.04. What is the ratio of the Imports(as % of merchandise exports) of Sub-Saharan Africa (developing only) in 2000 to that in 2009?
Your answer should be compact. 1.01. What is the ratio of the Imports(as % of merchandise exports) of Hungary in 2000 to that in 2009?
Give a very brief answer. 0.55. What is the ratio of the Imports(as % of merchandise exports) in Panama in 2000 to that in 2009?
Offer a terse response. 1.47. What is the ratio of the Imports(as % of merchandise exports) of Low income in 2000 to that in 2010?
Give a very brief answer. 1.1. What is the ratio of the Imports(as % of merchandise exports) in Sub-Saharan Africa (developing only) in 2000 to that in 2010?
Provide a short and direct response. 1.06. What is the ratio of the Imports(as % of merchandise exports) in Hungary in 2000 to that in 2010?
Keep it short and to the point. 0.59. What is the ratio of the Imports(as % of merchandise exports) in Panama in 2000 to that in 2010?
Offer a terse response. 1.46. What is the ratio of the Imports(as % of merchandise exports) in Low income in 2001 to that in 2002?
Keep it short and to the point. 0.99. What is the ratio of the Imports(as % of merchandise exports) in Sub-Saharan Africa (developing only) in 2001 to that in 2002?
Offer a very short reply. 0.98. What is the ratio of the Imports(as % of merchandise exports) in Hungary in 2001 to that in 2002?
Your response must be concise. 0.96. What is the ratio of the Imports(as % of merchandise exports) of Panama in 2001 to that in 2002?
Give a very brief answer. 0.9. What is the ratio of the Imports(as % of merchandise exports) in Low income in 2001 to that in 2008?
Your answer should be compact. 1.11. What is the ratio of the Imports(as % of merchandise exports) in Sub-Saharan Africa (developing only) in 2001 to that in 2008?
Provide a succinct answer. 1.21. What is the ratio of the Imports(as % of merchandise exports) in Hungary in 2001 to that in 2008?
Offer a terse response. 0.7. What is the ratio of the Imports(as % of merchandise exports) in Panama in 2001 to that in 2008?
Give a very brief answer. 1.55. What is the ratio of the Imports(as % of merchandise exports) in Low income in 2001 to that in 2009?
Provide a succinct answer. 1.09. What is the ratio of the Imports(as % of merchandise exports) in Sub-Saharan Africa (developing only) in 2001 to that in 2009?
Give a very brief answer. 1.05. What is the ratio of the Imports(as % of merchandise exports) of Hungary in 2001 to that in 2009?
Provide a succinct answer. 0.59. What is the ratio of the Imports(as % of merchandise exports) of Panama in 2001 to that in 2009?
Your answer should be compact. 1.52. What is the ratio of the Imports(as % of merchandise exports) of Low income in 2001 to that in 2010?
Your answer should be compact. 1.16. What is the ratio of the Imports(as % of merchandise exports) in Sub-Saharan Africa (developing only) in 2001 to that in 2010?
Your answer should be compact. 1.1. What is the ratio of the Imports(as % of merchandise exports) of Hungary in 2001 to that in 2010?
Your answer should be compact. 0.63. What is the ratio of the Imports(as % of merchandise exports) of Panama in 2001 to that in 2010?
Make the answer very short. 1.51. What is the ratio of the Imports(as % of merchandise exports) in Low income in 2002 to that in 2008?
Your response must be concise. 1.12. What is the ratio of the Imports(as % of merchandise exports) of Sub-Saharan Africa (developing only) in 2002 to that in 2008?
Ensure brevity in your answer.  1.23. What is the ratio of the Imports(as % of merchandise exports) in Hungary in 2002 to that in 2008?
Your answer should be compact. 0.72. What is the ratio of the Imports(as % of merchandise exports) in Panama in 2002 to that in 2008?
Provide a short and direct response. 1.73. What is the ratio of the Imports(as % of merchandise exports) of Low income in 2002 to that in 2009?
Offer a terse response. 1.1. What is the ratio of the Imports(as % of merchandise exports) in Sub-Saharan Africa (developing only) in 2002 to that in 2009?
Offer a terse response. 1.07. What is the ratio of the Imports(as % of merchandise exports) of Hungary in 2002 to that in 2009?
Your answer should be compact. 0.61. What is the ratio of the Imports(as % of merchandise exports) in Panama in 2002 to that in 2009?
Give a very brief answer. 1.69. What is the ratio of the Imports(as % of merchandise exports) in Low income in 2002 to that in 2010?
Ensure brevity in your answer.  1.17. What is the ratio of the Imports(as % of merchandise exports) of Sub-Saharan Africa (developing only) in 2002 to that in 2010?
Provide a short and direct response. 1.12. What is the ratio of the Imports(as % of merchandise exports) in Hungary in 2002 to that in 2010?
Provide a succinct answer. 0.66. What is the ratio of the Imports(as % of merchandise exports) of Panama in 2002 to that in 2010?
Give a very brief answer. 1.68. What is the ratio of the Imports(as % of merchandise exports) of Low income in 2008 to that in 2009?
Your answer should be very brief. 0.98. What is the ratio of the Imports(as % of merchandise exports) of Sub-Saharan Africa (developing only) in 2008 to that in 2009?
Offer a very short reply. 0.87. What is the ratio of the Imports(as % of merchandise exports) in Hungary in 2008 to that in 2009?
Your answer should be compact. 0.84. What is the ratio of the Imports(as % of merchandise exports) in Panama in 2008 to that in 2009?
Offer a very short reply. 0.98. What is the ratio of the Imports(as % of merchandise exports) of Low income in 2008 to that in 2010?
Your answer should be compact. 1.04. What is the ratio of the Imports(as % of merchandise exports) of Sub-Saharan Africa (developing only) in 2008 to that in 2010?
Your answer should be very brief. 0.91. What is the ratio of the Imports(as % of merchandise exports) in Hungary in 2008 to that in 2010?
Make the answer very short. 0.91. What is the ratio of the Imports(as % of merchandise exports) in Panama in 2008 to that in 2010?
Ensure brevity in your answer.  0.97. What is the ratio of the Imports(as % of merchandise exports) of Low income in 2009 to that in 2010?
Offer a very short reply. 1.06. What is the ratio of the Imports(as % of merchandise exports) of Sub-Saharan Africa (developing only) in 2009 to that in 2010?
Your answer should be very brief. 1.05. What is the ratio of the Imports(as % of merchandise exports) of Hungary in 2009 to that in 2010?
Your answer should be very brief. 1.07. What is the difference between the highest and the second highest Imports(as % of merchandise exports) of Low income?
Make the answer very short. 0.14. What is the difference between the highest and the second highest Imports(as % of merchandise exports) of Sub-Saharan Africa (developing only)?
Provide a succinct answer. 0.2. What is the difference between the highest and the second highest Imports(as % of merchandise exports) in Hungary?
Your answer should be compact. 0.36. What is the difference between the highest and the second highest Imports(as % of merchandise exports) of Panama?
Offer a terse response. 1.35. What is the difference between the highest and the lowest Imports(as % of merchandise exports) of Low income?
Offer a terse response. 2.22. What is the difference between the highest and the lowest Imports(as % of merchandise exports) in Sub-Saharan Africa (developing only)?
Your answer should be compact. 2.41. What is the difference between the highest and the lowest Imports(as % of merchandise exports) of Hungary?
Give a very brief answer. 2.35. What is the difference between the highest and the lowest Imports(as % of merchandise exports) of Panama?
Offer a terse response. 5.65. 